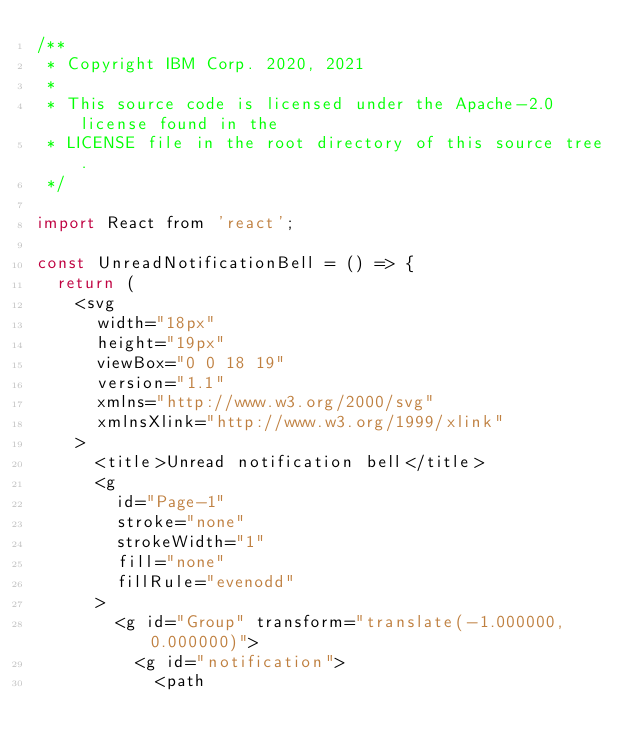Convert code to text. <code><loc_0><loc_0><loc_500><loc_500><_JavaScript_>/**
 * Copyright IBM Corp. 2020, 2021
 *
 * This source code is licensed under the Apache-2.0 license found in the
 * LICENSE file in the root directory of this source tree.
 */

import React from 'react';

const UnreadNotificationBell = () => {
  return (
    <svg
      width="18px"
      height="19px"
      viewBox="0 0 18 19"
      version="1.1"
      xmlns="http://www.w3.org/2000/svg"
      xmlnsXlink="http://www.w3.org/1999/xlink"
    >
      <title>Unread notification bell</title>
      <g
        id="Page-1"
        stroke="none"
        strokeWidth="1"
        fill="none"
        fillRule="evenodd"
      >
        <g id="Group" transform="translate(-1.000000, 0.000000)">
          <g id="notification">
            <path</code> 